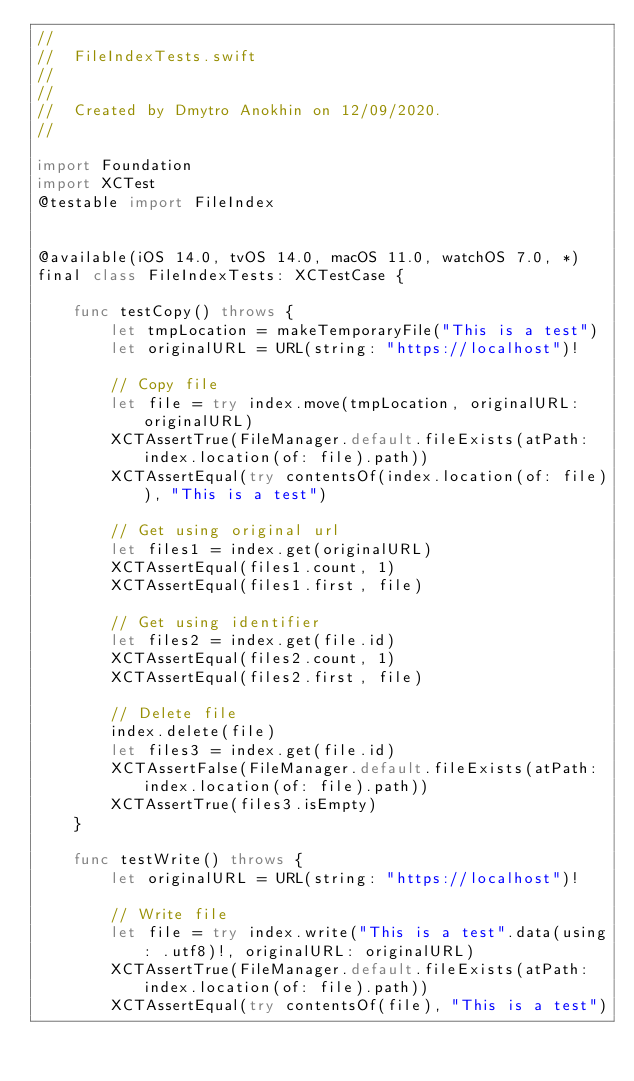<code> <loc_0><loc_0><loc_500><loc_500><_Swift_>//
//  FileIndexTests.swift
//  
//
//  Created by Dmytro Anokhin on 12/09/2020.
//

import Foundation
import XCTest
@testable import FileIndex


@available(iOS 14.0, tvOS 14.0, macOS 11.0, watchOS 7.0, *)
final class FileIndexTests: XCTestCase {

    func testCopy() throws {
        let tmpLocation = makeTemporaryFile("This is a test")
        let originalURL = URL(string: "https://localhost")!

        // Copy file
        let file = try index.move(tmpLocation, originalURL: originalURL)
        XCTAssertTrue(FileManager.default.fileExists(atPath: index.location(of: file).path))
        XCTAssertEqual(try contentsOf(index.location(of: file)), "This is a test")

        // Get using original url
        let files1 = index.get(originalURL)
        XCTAssertEqual(files1.count, 1)
        XCTAssertEqual(files1.first, file)

        // Get using identifier
        let files2 = index.get(file.id)
        XCTAssertEqual(files2.count, 1)
        XCTAssertEqual(files2.first, file)

        // Delete file
        index.delete(file)
        let files3 = index.get(file.id)
        XCTAssertFalse(FileManager.default.fileExists(atPath: index.location(of: file).path))
        XCTAssertTrue(files3.isEmpty)
    }

    func testWrite() throws {
        let originalURL = URL(string: "https://localhost")!

        // Write file
        let file = try index.write("This is a test".data(using: .utf8)!, originalURL: originalURL)
        XCTAssertTrue(FileManager.default.fileExists(atPath: index.location(of: file).path))
        XCTAssertEqual(try contentsOf(file), "This is a test")
</code> 